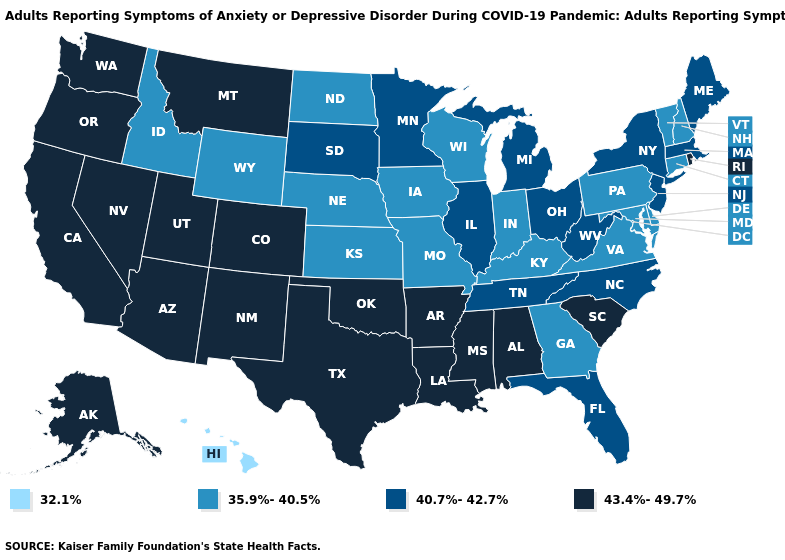Does Hawaii have the lowest value in the USA?
Short answer required. Yes. What is the highest value in the USA?
Answer briefly. 43.4%-49.7%. Which states have the highest value in the USA?
Concise answer only. Alabama, Alaska, Arizona, Arkansas, California, Colorado, Louisiana, Mississippi, Montana, Nevada, New Mexico, Oklahoma, Oregon, Rhode Island, South Carolina, Texas, Utah, Washington. Does Connecticut have the lowest value in the Northeast?
Answer briefly. Yes. Name the states that have a value in the range 40.7%-42.7%?
Give a very brief answer. Florida, Illinois, Maine, Massachusetts, Michigan, Minnesota, New Jersey, New York, North Carolina, Ohio, South Dakota, Tennessee, West Virginia. Which states have the lowest value in the West?
Concise answer only. Hawaii. Which states have the lowest value in the South?
Quick response, please. Delaware, Georgia, Kentucky, Maryland, Virginia. Does Michigan have the highest value in the USA?
Give a very brief answer. No. What is the lowest value in the South?
Keep it brief. 35.9%-40.5%. Which states have the lowest value in the USA?
Short answer required. Hawaii. What is the lowest value in the USA?
Short answer required. 32.1%. Name the states that have a value in the range 35.9%-40.5%?
Answer briefly. Connecticut, Delaware, Georgia, Idaho, Indiana, Iowa, Kansas, Kentucky, Maryland, Missouri, Nebraska, New Hampshire, North Dakota, Pennsylvania, Vermont, Virginia, Wisconsin, Wyoming. Among the states that border Colorado , which have the lowest value?
Answer briefly. Kansas, Nebraska, Wyoming. How many symbols are there in the legend?
Keep it brief. 4. What is the highest value in states that border West Virginia?
Quick response, please. 40.7%-42.7%. 